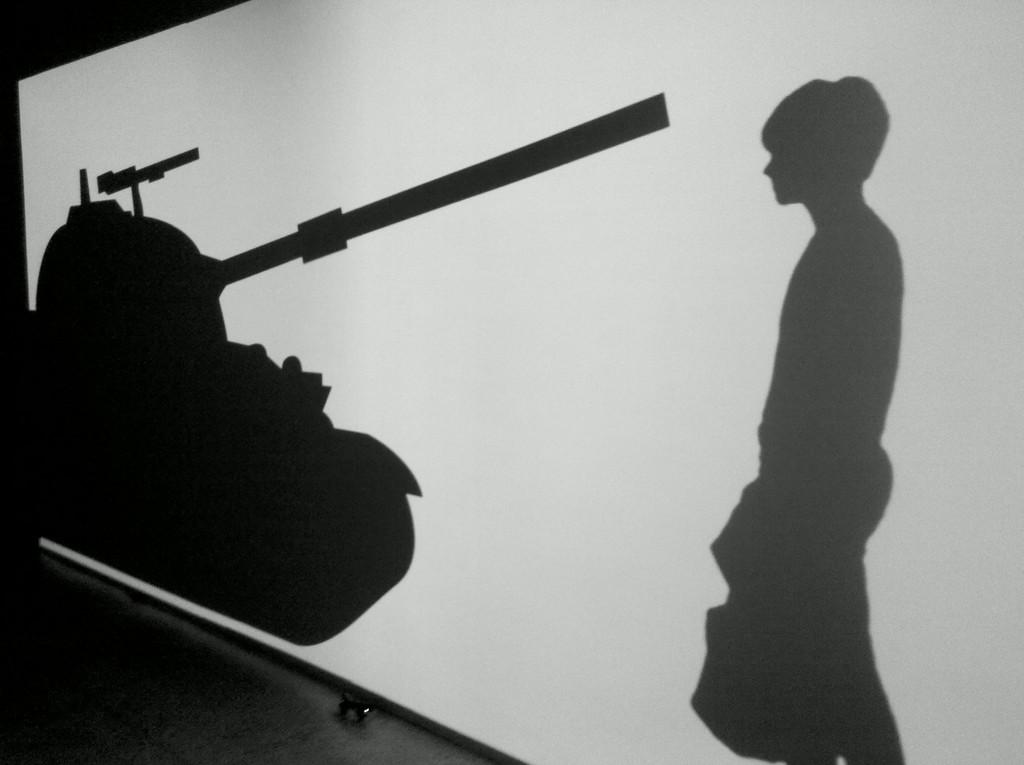What is the main subject in the image? There is a person standing in the image. What other object is present in the image? There is a battle tank in the image. Where are the person and the battle tank located? Both the person and the battle tank are on a screen. What type of trousers is the person wearing in the image? There is no information about the person's trousers in the image, so it cannot be determined. 